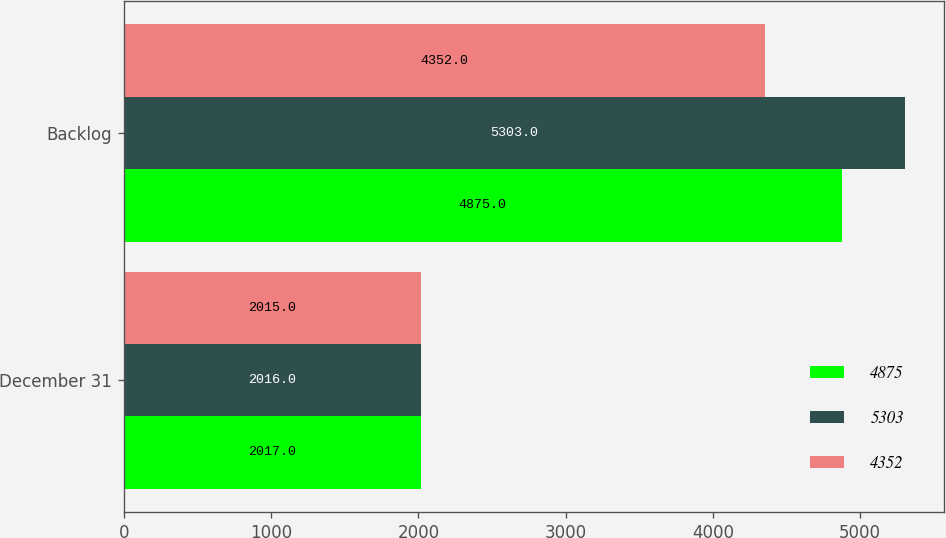Convert chart. <chart><loc_0><loc_0><loc_500><loc_500><stacked_bar_chart><ecel><fcel>December 31<fcel>Backlog<nl><fcel>4875<fcel>2017<fcel>4875<nl><fcel>5303<fcel>2016<fcel>5303<nl><fcel>4352<fcel>2015<fcel>4352<nl></chart> 